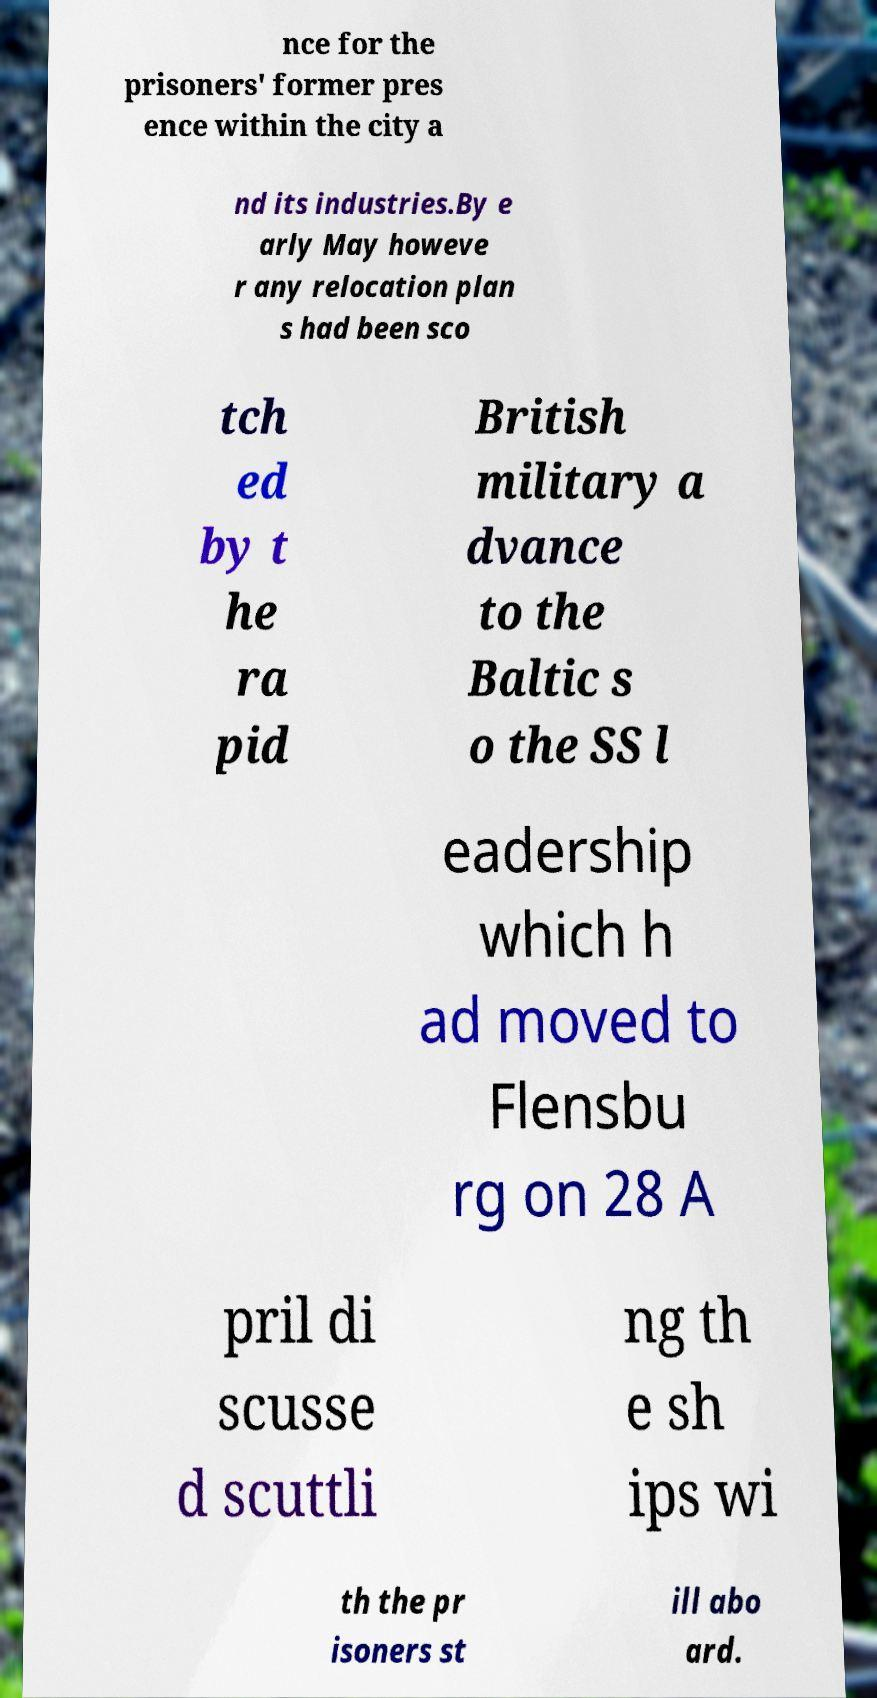What messages or text are displayed in this image? I need them in a readable, typed format. nce for the prisoners' former pres ence within the city a nd its industries.By e arly May howeve r any relocation plan s had been sco tch ed by t he ra pid British military a dvance to the Baltic s o the SS l eadership which h ad moved to Flensbu rg on 28 A pril di scusse d scuttli ng th e sh ips wi th the pr isoners st ill abo ard. 